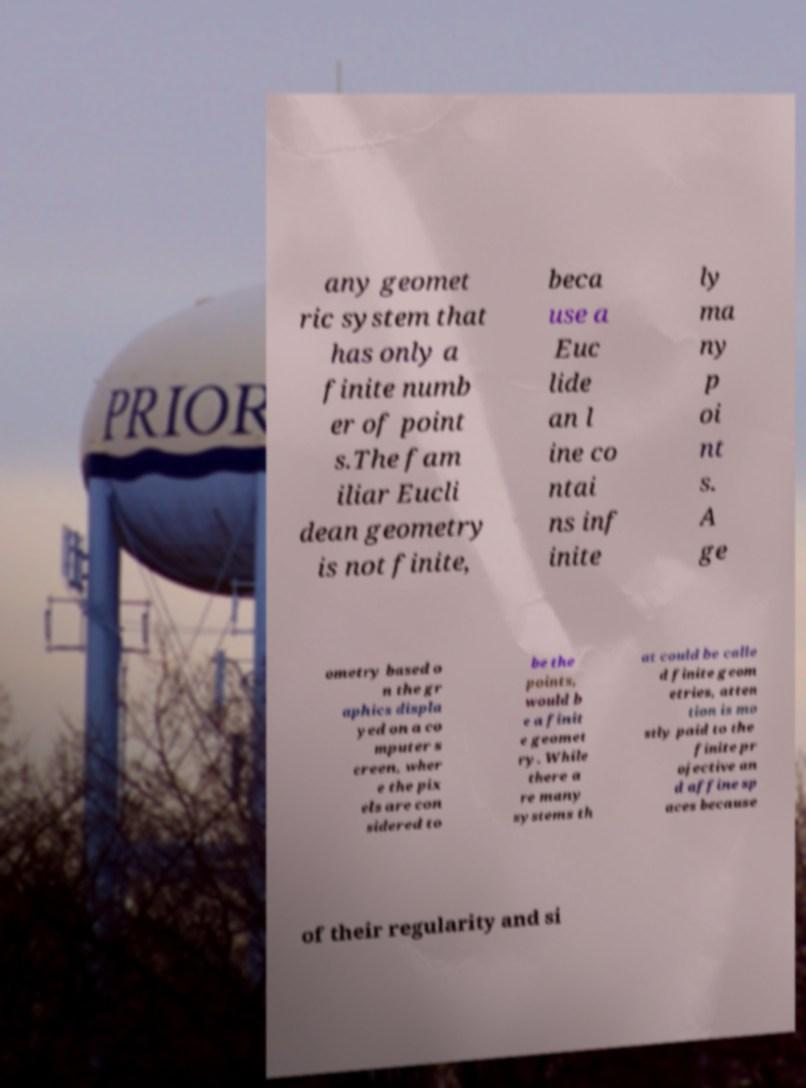There's text embedded in this image that I need extracted. Can you transcribe it verbatim? any geomet ric system that has only a finite numb er of point s.The fam iliar Eucli dean geometry is not finite, beca use a Euc lide an l ine co ntai ns inf inite ly ma ny p oi nt s. A ge ometry based o n the gr aphics displa yed on a co mputer s creen, wher e the pix els are con sidered to be the points, would b e a finit e geomet ry. While there a re many systems th at could be calle d finite geom etries, atten tion is mo stly paid to the finite pr ojective an d affine sp aces because of their regularity and si 